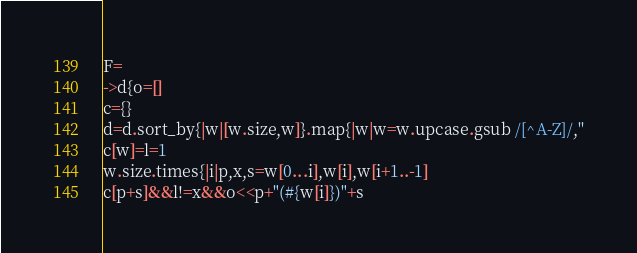Convert code to text. <code><loc_0><loc_0><loc_500><loc_500><_Ruby_>
F=
->d{o=[]
c={}
d=d.sort_by{|w|[w.size,w]}.map{|w|w=w.upcase.gsub /[^A-Z]/,''
c[w]=l=1
w.size.times{|i|p,x,s=w[0...i],w[i],w[i+1..-1]
c[p+s]&&l!=x&&o<<p+"(#{w[i]})"+s</code> 